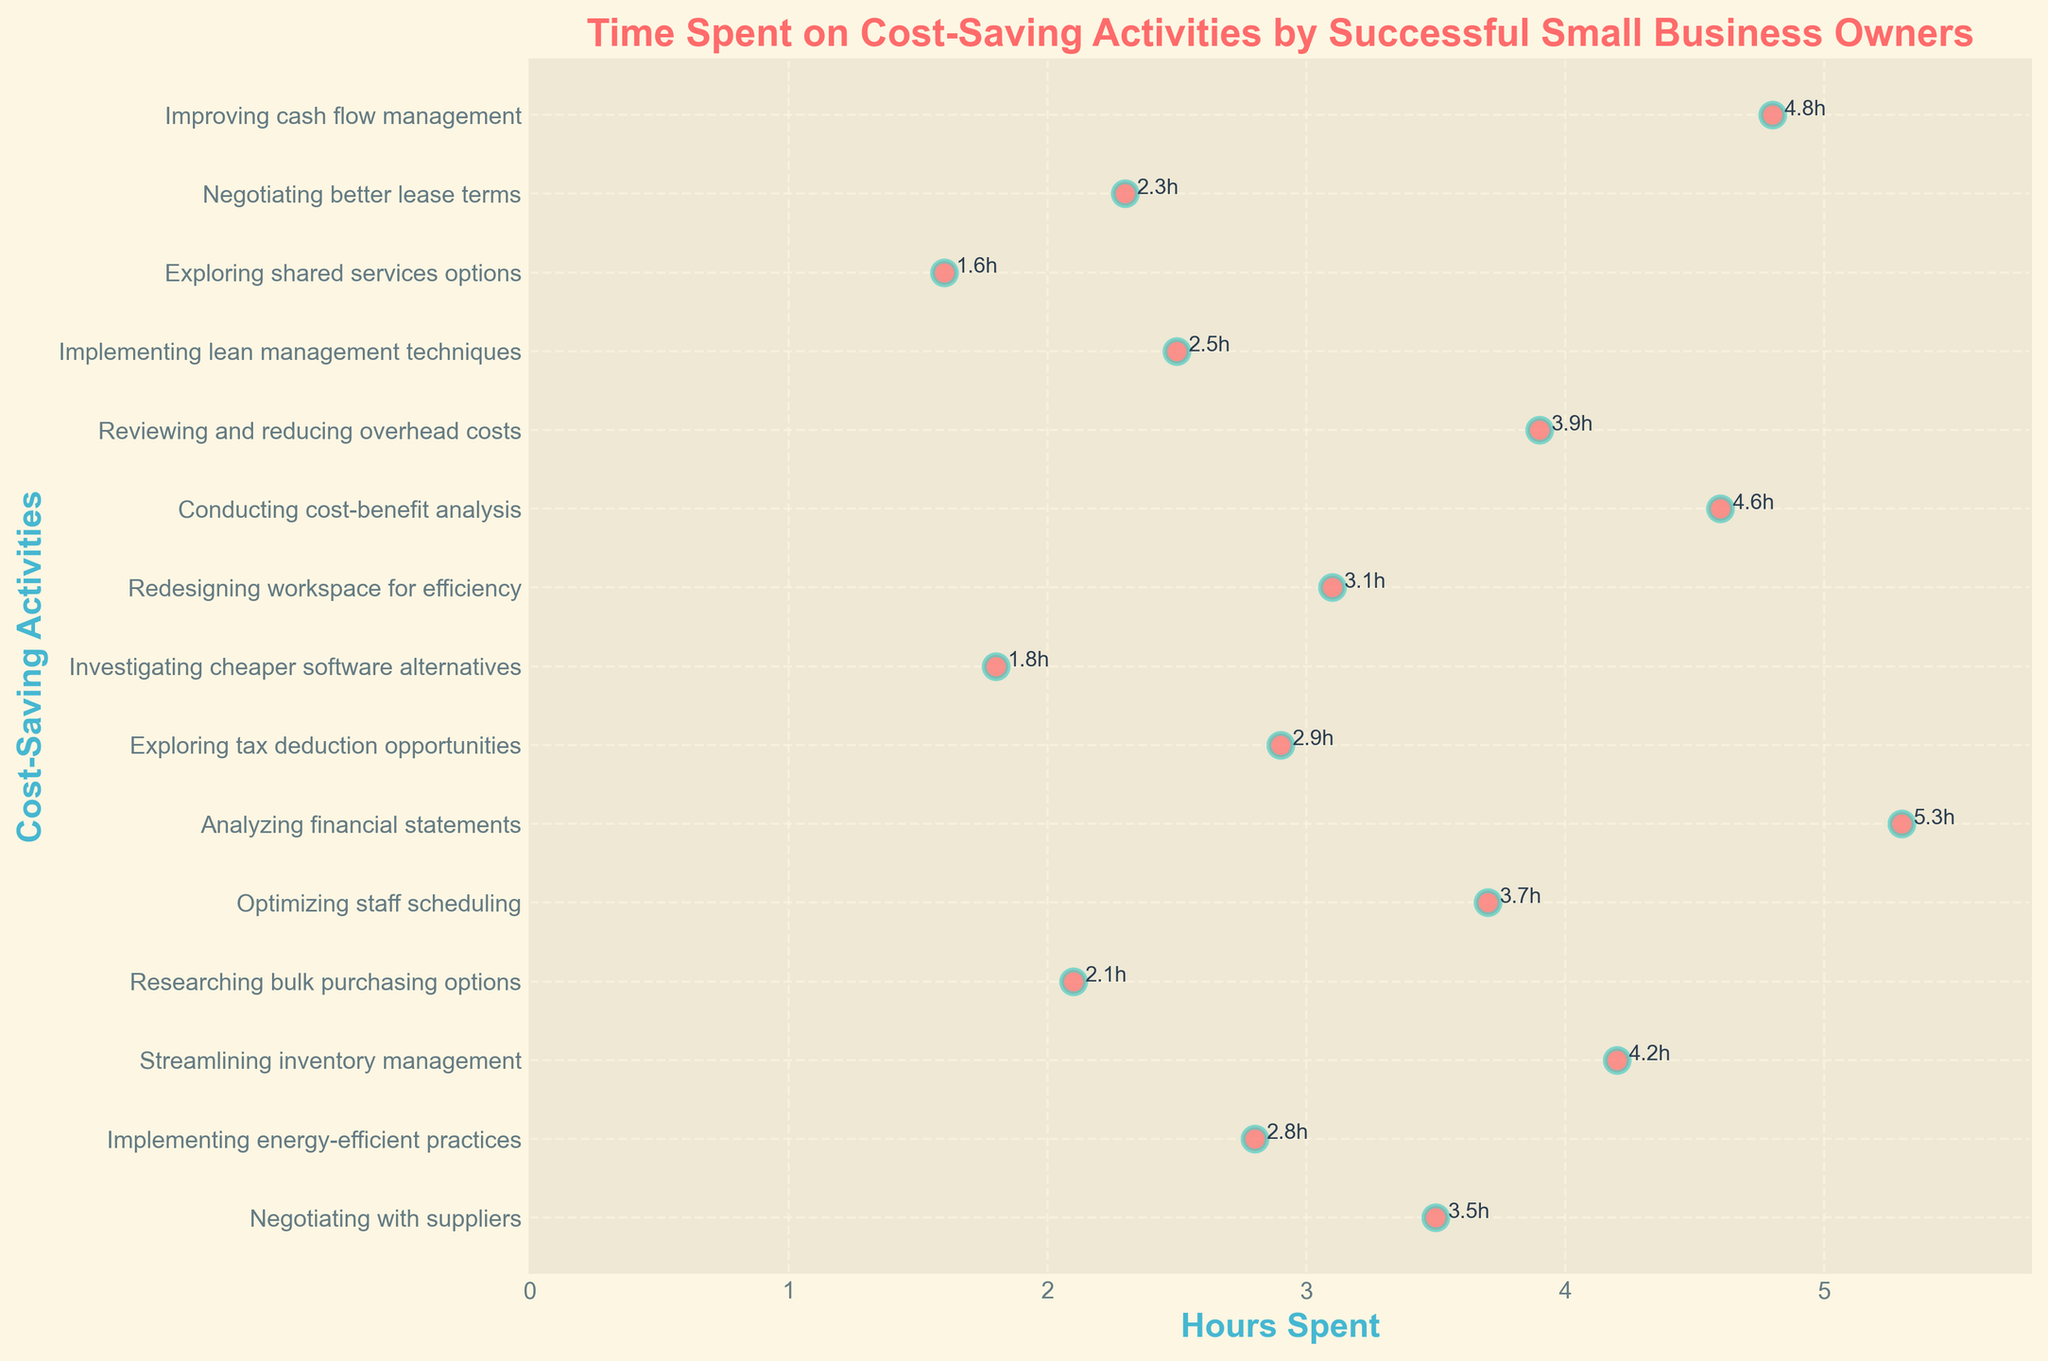What is the title of the figure? The title is found at the top of the figure, usually in a larger and bolder font. It provides a concise description of the plot's content. Here, the title is "Time Spent on Cost-Saving Activities by Successful Small Business Owners".
Answer: Time Spent on Cost-Saving Activities by Successful Small Business Owners What is the activity with the highest time spent? By looking for the highest data point on the x-axis, we see that "Analyzing financial statements" has the highest time spent with 5.3 hours.
Answer: Analyzing financial statements Which two activities have a time spent difference of 3 hours? To find this, we look at the x-axis values and identify pairs where the difference is 3. "Analyzing financial statements" (5.3 hours) and "Investigating cheaper software alternatives" (1.8 hours) meet this criterion: 5.3 - 1.8 = 3.5.
Answer: Analyzing financial statements and Investigating cheaper software alternatives What is the average time spent on all activities? Sum all the hours spent on each activity and divide by the number of activities. Sum: 3.5 + 2.8 + 4.2 + 2.1 + 3.7 + 5.3 + 2.9 + 1.8 + 3.1 + 4.6 + 3.9 + 2.5 + 1.6 + 2.3 + 4.8 = 45. On average: 45 / 15 activities = 3 hours.
Answer: 3 hours Which activity took the least amount of time? Examine the data points on the x-axis and find the smallest value. "Exploring shared services options" has the lowest value of 1.6 hours.
Answer: Exploring shared services options What is the difference in time spent between the activities "Reviewing and reducing overhead costs" and "Investigating cheaper software alternatives"? Find the x-axis values for these activities and subtract them. "Reviewing and reducing overhead costs" is 3.9 hours, and "Investigating cheaper software alternatives" is 1.8 hours. Difference: 3.9 - 1.8 = 2.1 hours.
Answer: 2.1 hours How many activities took more than 4 hours? Count the number of data points where the x-axis value is greater than 4. They are: "Streamlining inventory management" (4.2), "Analyzing financial statements" (5.3), "Conducting cost-benefit analysis" (4.6), "Improving cash flow management" (4.8). So, there are four activities.
Answer: 4 What is the median time spent across all activities? List the hours in ascending order and find the middle value. Sorted hours: 1.6, 1.8, 2.1, 2.3, 2.5, 2.8, 2.9, 3.1, 3.5, 3.7, 3.9, 4.2, 4.6, 4.8, 5.3. The middle value (8th position) is 2.9 hours.
Answer: 2.9 hours 